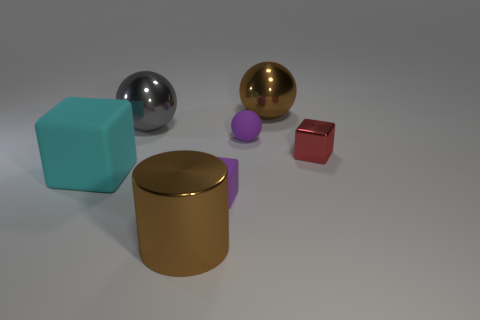If these objects were part of a game, what kind of game could it be? If these objects were part of a game, it could be a physics puzzle game where the player has to arrange the objects according to specific rules or criteria, such as sorting by material, color, or size. The varying sizes and materials could add complexity to the game, requiring inventive strategies to solve the puzzles. 